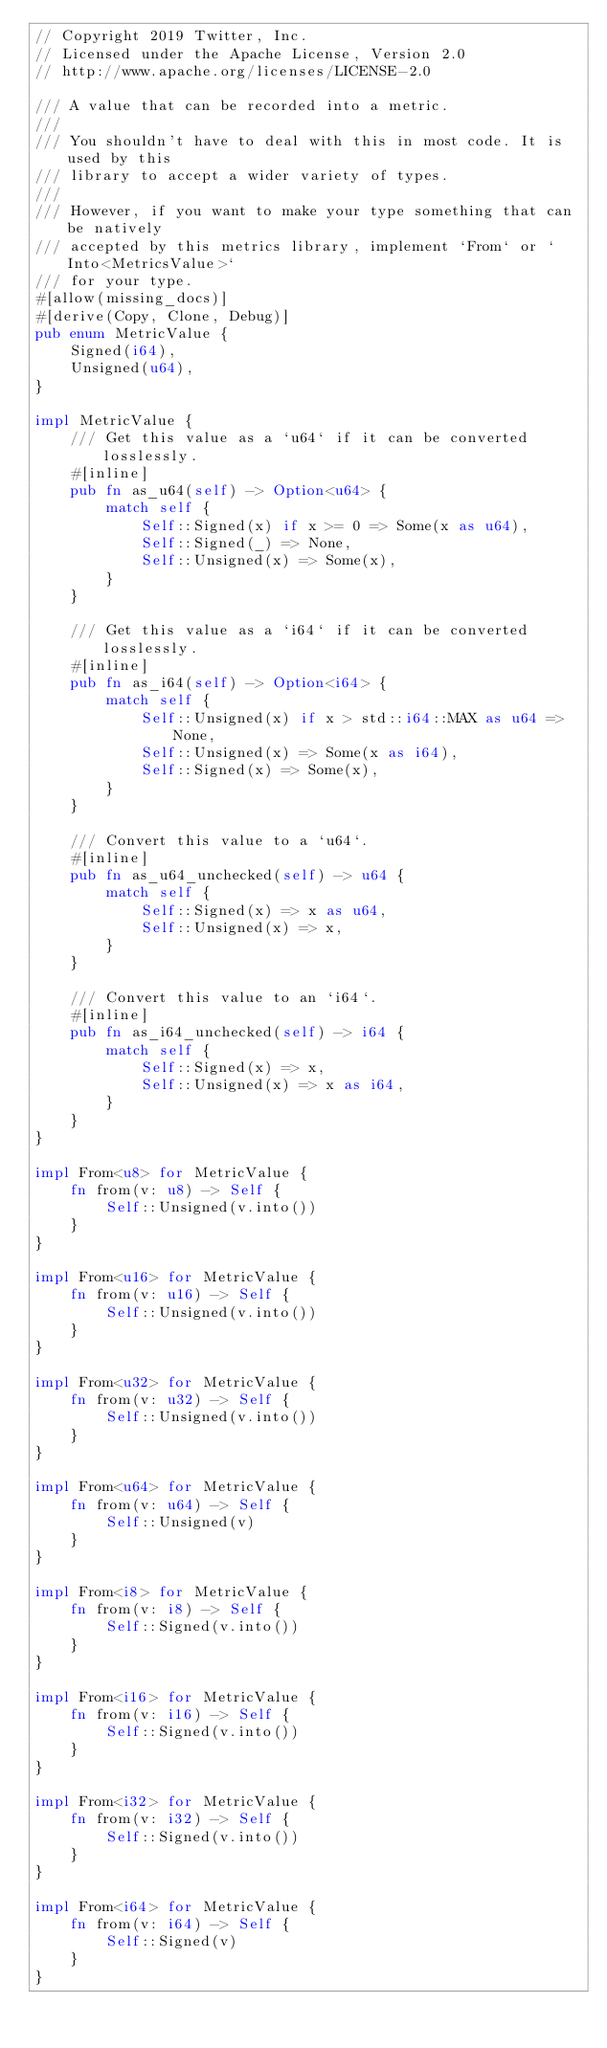<code> <loc_0><loc_0><loc_500><loc_500><_Rust_>// Copyright 2019 Twitter, Inc.
// Licensed under the Apache License, Version 2.0
// http://www.apache.org/licenses/LICENSE-2.0

/// A value that can be recorded into a metric.
///
/// You shouldn't have to deal with this in most code. It is used by this
/// library to accept a wider variety of types.
///
/// However, if you want to make your type something that can be natively
/// accepted by this metrics library, implement `From` or `Into<MetricsValue>`
/// for your type.
#[allow(missing_docs)]
#[derive(Copy, Clone, Debug)]
pub enum MetricValue {
    Signed(i64),
    Unsigned(u64),
}

impl MetricValue {
    /// Get this value as a `u64` if it can be converted losslessly.
    #[inline]
    pub fn as_u64(self) -> Option<u64> {
        match self {
            Self::Signed(x) if x >= 0 => Some(x as u64),
            Self::Signed(_) => None,
            Self::Unsigned(x) => Some(x),
        }
    }

    /// Get this value as a `i64` if it can be converted losslessly.
    #[inline]
    pub fn as_i64(self) -> Option<i64> {
        match self {
            Self::Unsigned(x) if x > std::i64::MAX as u64 => None,
            Self::Unsigned(x) => Some(x as i64),
            Self::Signed(x) => Some(x),
        }
    }

    /// Convert this value to a `u64`.
    #[inline]
    pub fn as_u64_unchecked(self) -> u64 {
        match self {
            Self::Signed(x) => x as u64,
            Self::Unsigned(x) => x,
        }
    }

    /// Convert this value to an `i64`.
    #[inline]
    pub fn as_i64_unchecked(self) -> i64 {
        match self {
            Self::Signed(x) => x,
            Self::Unsigned(x) => x as i64,
        }
    }
}

impl From<u8> for MetricValue {
    fn from(v: u8) -> Self {
        Self::Unsigned(v.into())
    }
}

impl From<u16> for MetricValue {
    fn from(v: u16) -> Self {
        Self::Unsigned(v.into())
    }
}

impl From<u32> for MetricValue {
    fn from(v: u32) -> Self {
        Self::Unsigned(v.into())
    }
}

impl From<u64> for MetricValue {
    fn from(v: u64) -> Self {
        Self::Unsigned(v)
    }
}

impl From<i8> for MetricValue {
    fn from(v: i8) -> Self {
        Self::Signed(v.into())
    }
}

impl From<i16> for MetricValue {
    fn from(v: i16) -> Self {
        Self::Signed(v.into())
    }
}

impl From<i32> for MetricValue {
    fn from(v: i32) -> Self {
        Self::Signed(v.into())
    }
}

impl From<i64> for MetricValue {
    fn from(v: i64) -> Self {
        Self::Signed(v)
    }
}
</code> 